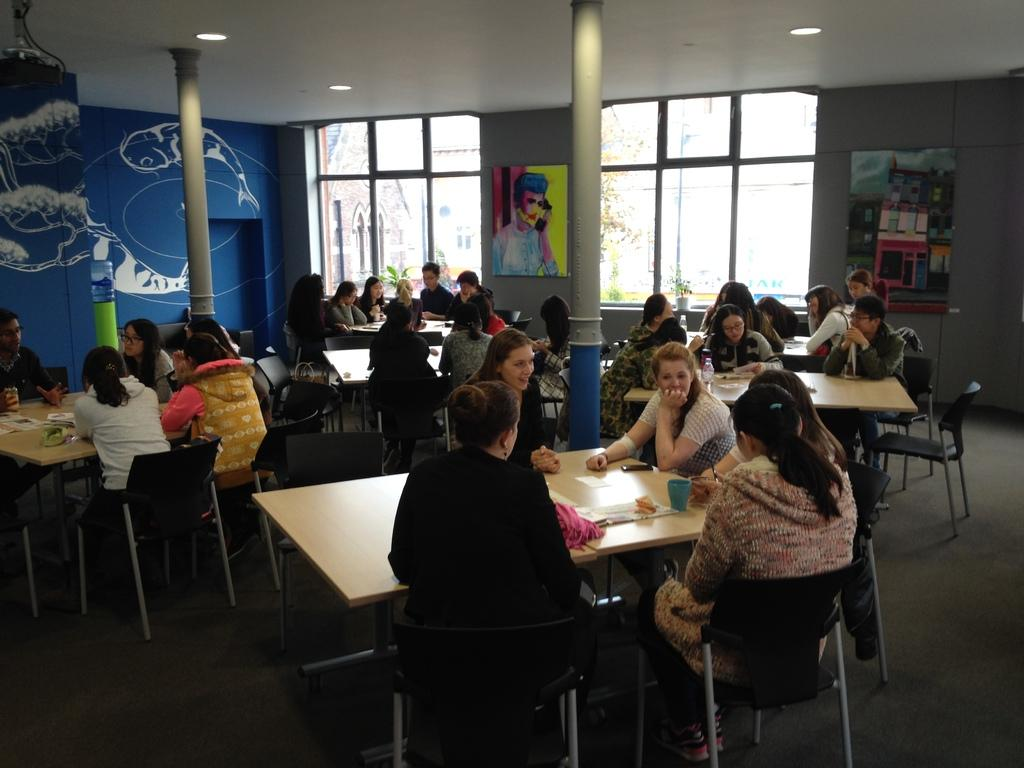How many people are in the image? There is a group of people in the image. What are the people doing in the image? The people are sitting on a chair. What is in front of the people? There is a table in front of the people. What can be seen in the background of the image? There is a pillar and a wall in the background of the image. What is visible at the top of the image? There is a light visible at the top of the image. What flavor of toothpaste is the baby using in the image? There is no baby or toothpaste present in the image. 